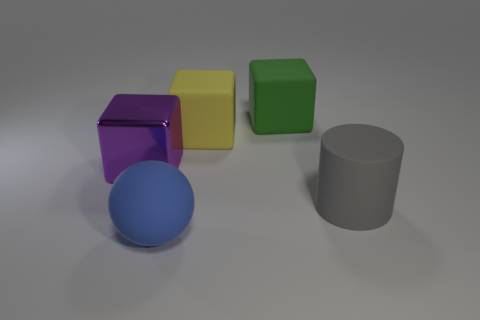Add 4 tiny things. How many objects exist? 9 Subtract all matte blocks. How many blocks are left? 1 Subtract 0 gray cubes. How many objects are left? 5 Subtract all cubes. How many objects are left? 2 Subtract 1 cylinders. How many cylinders are left? 0 Subtract all green spheres. Subtract all purple cylinders. How many spheres are left? 1 Subtract all purple balls. How many yellow blocks are left? 1 Subtract all green cubes. Subtract all rubber blocks. How many objects are left? 2 Add 5 large yellow rubber blocks. How many large yellow rubber blocks are left? 6 Add 3 tiny cyan spheres. How many tiny cyan spheres exist? 3 